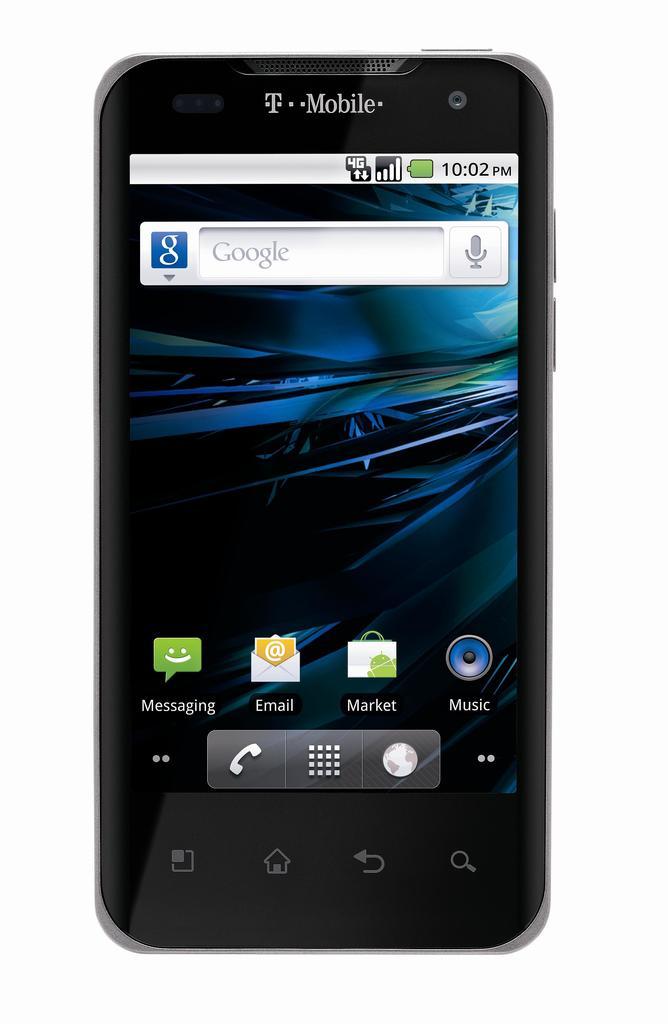What time is displayed?
Offer a terse response. 10:02. What carrier is the phone?
Your response must be concise. T-mobile. 